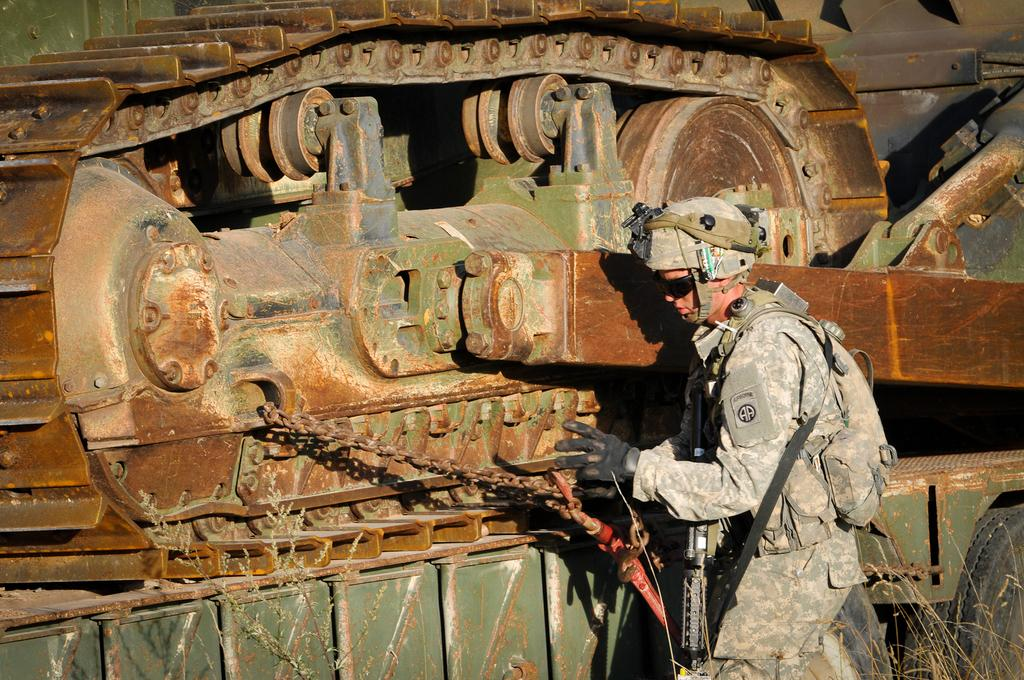What type of person is in the image? There is an army person in the image. What is the army person standing beside? The army person is standing beside a tanker. What protective gear is the army person wearing? The army person is wearing gloves and a helmet. What items is the army person carrying? The army person is carrying a bag and a gun. What type of appliance is the army person using in the image? There is no appliance present in the image; the army person is standing beside a tanker. What type of business is the army person conducting in the image? The image does not depict any business activity; it shows an army person standing beside a tanker. 